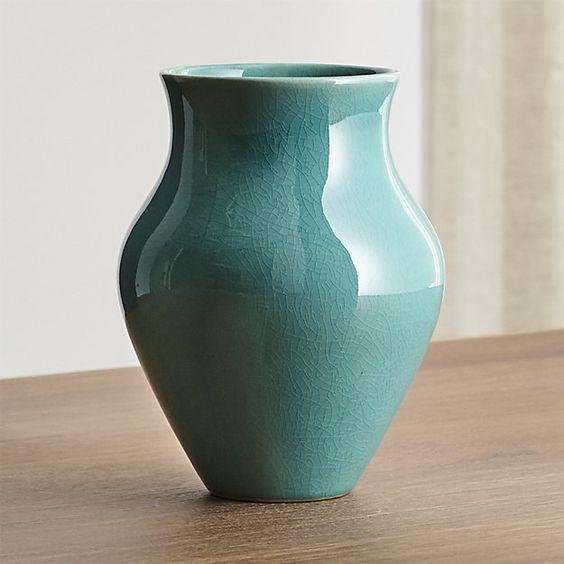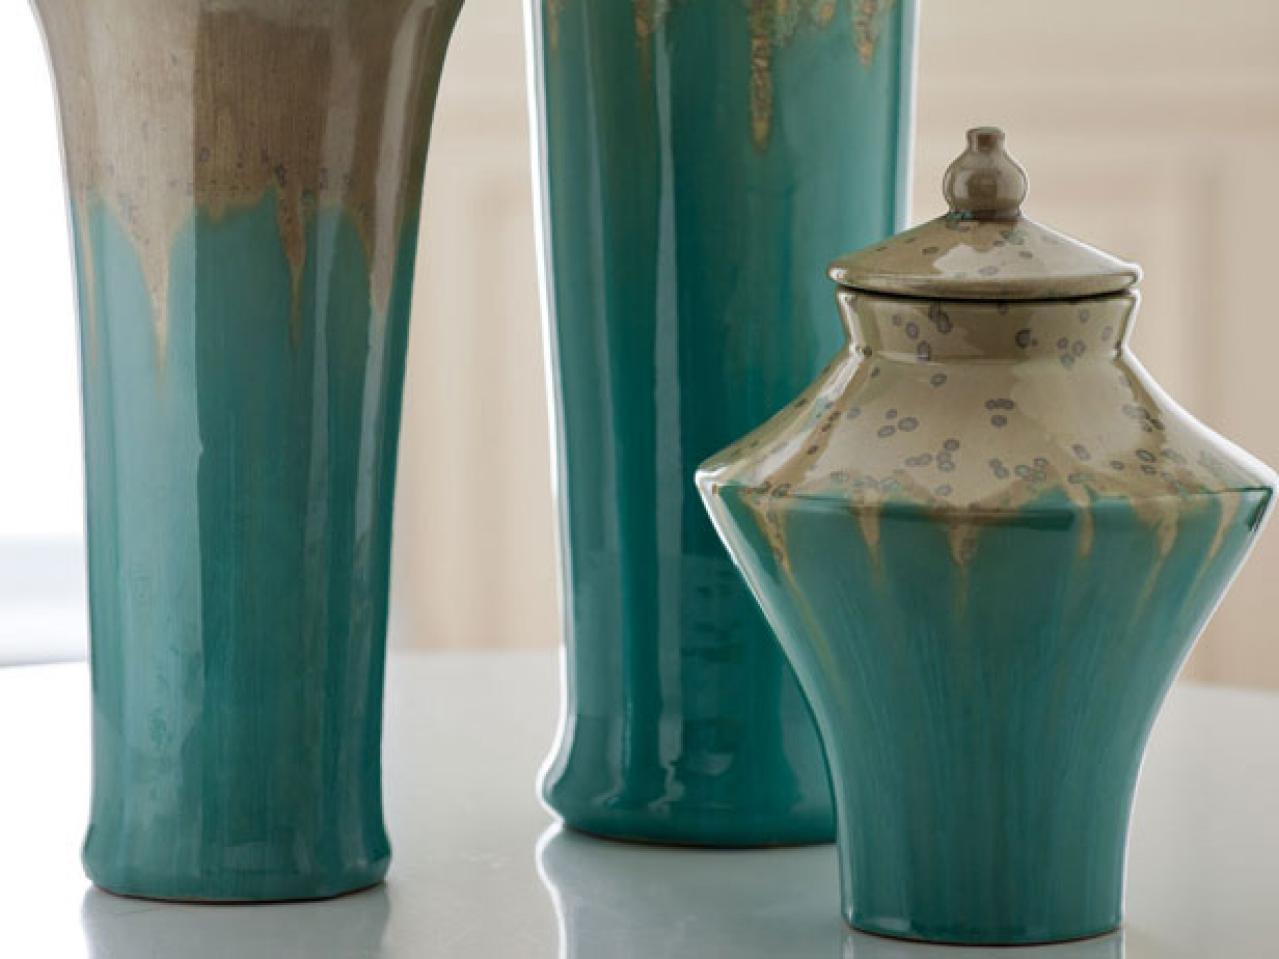The first image is the image on the left, the second image is the image on the right. Considering the images on both sides, is "Four pieces of turquoise blue pottery are shown." valid? Answer yes or no. Yes. The first image is the image on the left, the second image is the image on the right. For the images displayed, is the sentence "An image shows three turquoise blue vases." factually correct? Answer yes or no. Yes. 